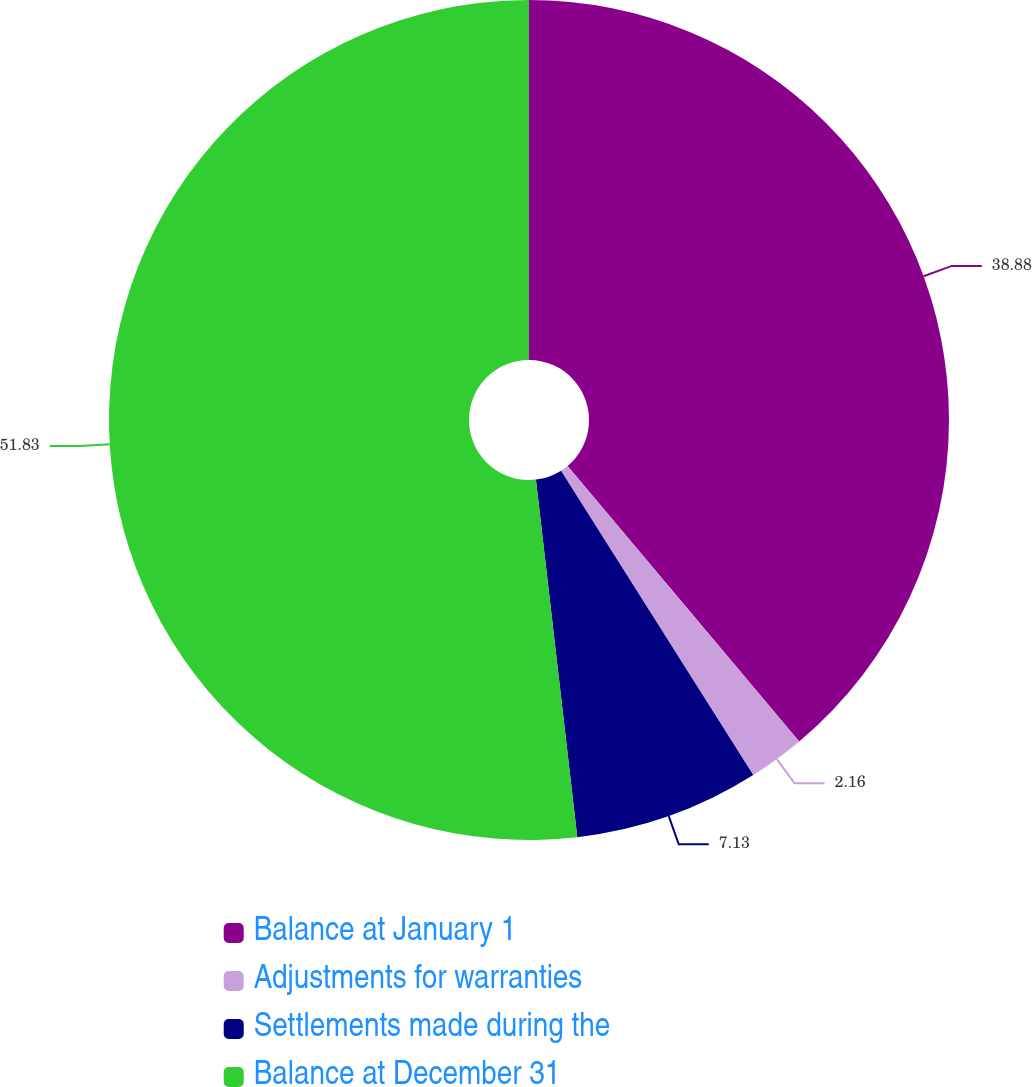Convert chart to OTSL. <chart><loc_0><loc_0><loc_500><loc_500><pie_chart><fcel>Balance at January 1<fcel>Adjustments for warranties<fcel>Settlements made during the<fcel>Balance at December 31<nl><fcel>38.88%<fcel>2.16%<fcel>7.13%<fcel>51.84%<nl></chart> 